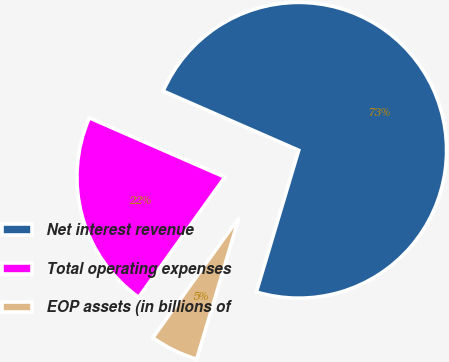<chart> <loc_0><loc_0><loc_500><loc_500><pie_chart><fcel>Net interest revenue<fcel>Total operating expenses<fcel>EOP assets (in billions of<nl><fcel>73.05%<fcel>21.66%<fcel>5.28%<nl></chart> 